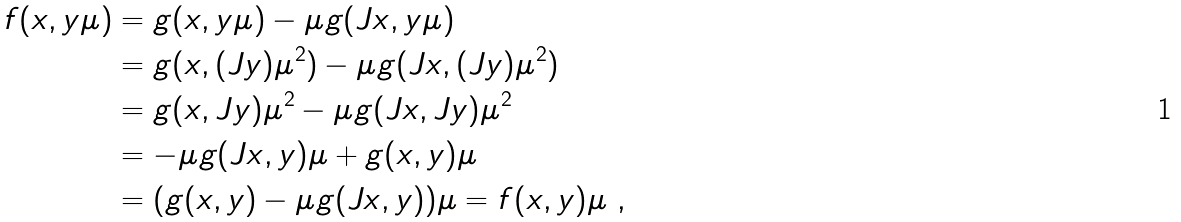Convert formula to latex. <formula><loc_0><loc_0><loc_500><loc_500>f ( x , y \mu ) & = g ( x , y \mu ) - \mu g ( J x , y \mu ) \\ & = g ( x , ( J y ) \mu ^ { 2 } ) - \mu g ( J x , ( J y ) \mu ^ { 2 } ) \\ & = g ( x , J y ) \mu ^ { 2 } - \mu g ( J x , J y ) \mu ^ { 2 } \\ & = - \mu g ( J x , y ) \mu + g ( x , y ) \mu \\ & = ( g ( x , y ) - \mu g ( J x , y ) ) \mu = f ( x , y ) \mu \ ,</formula> 